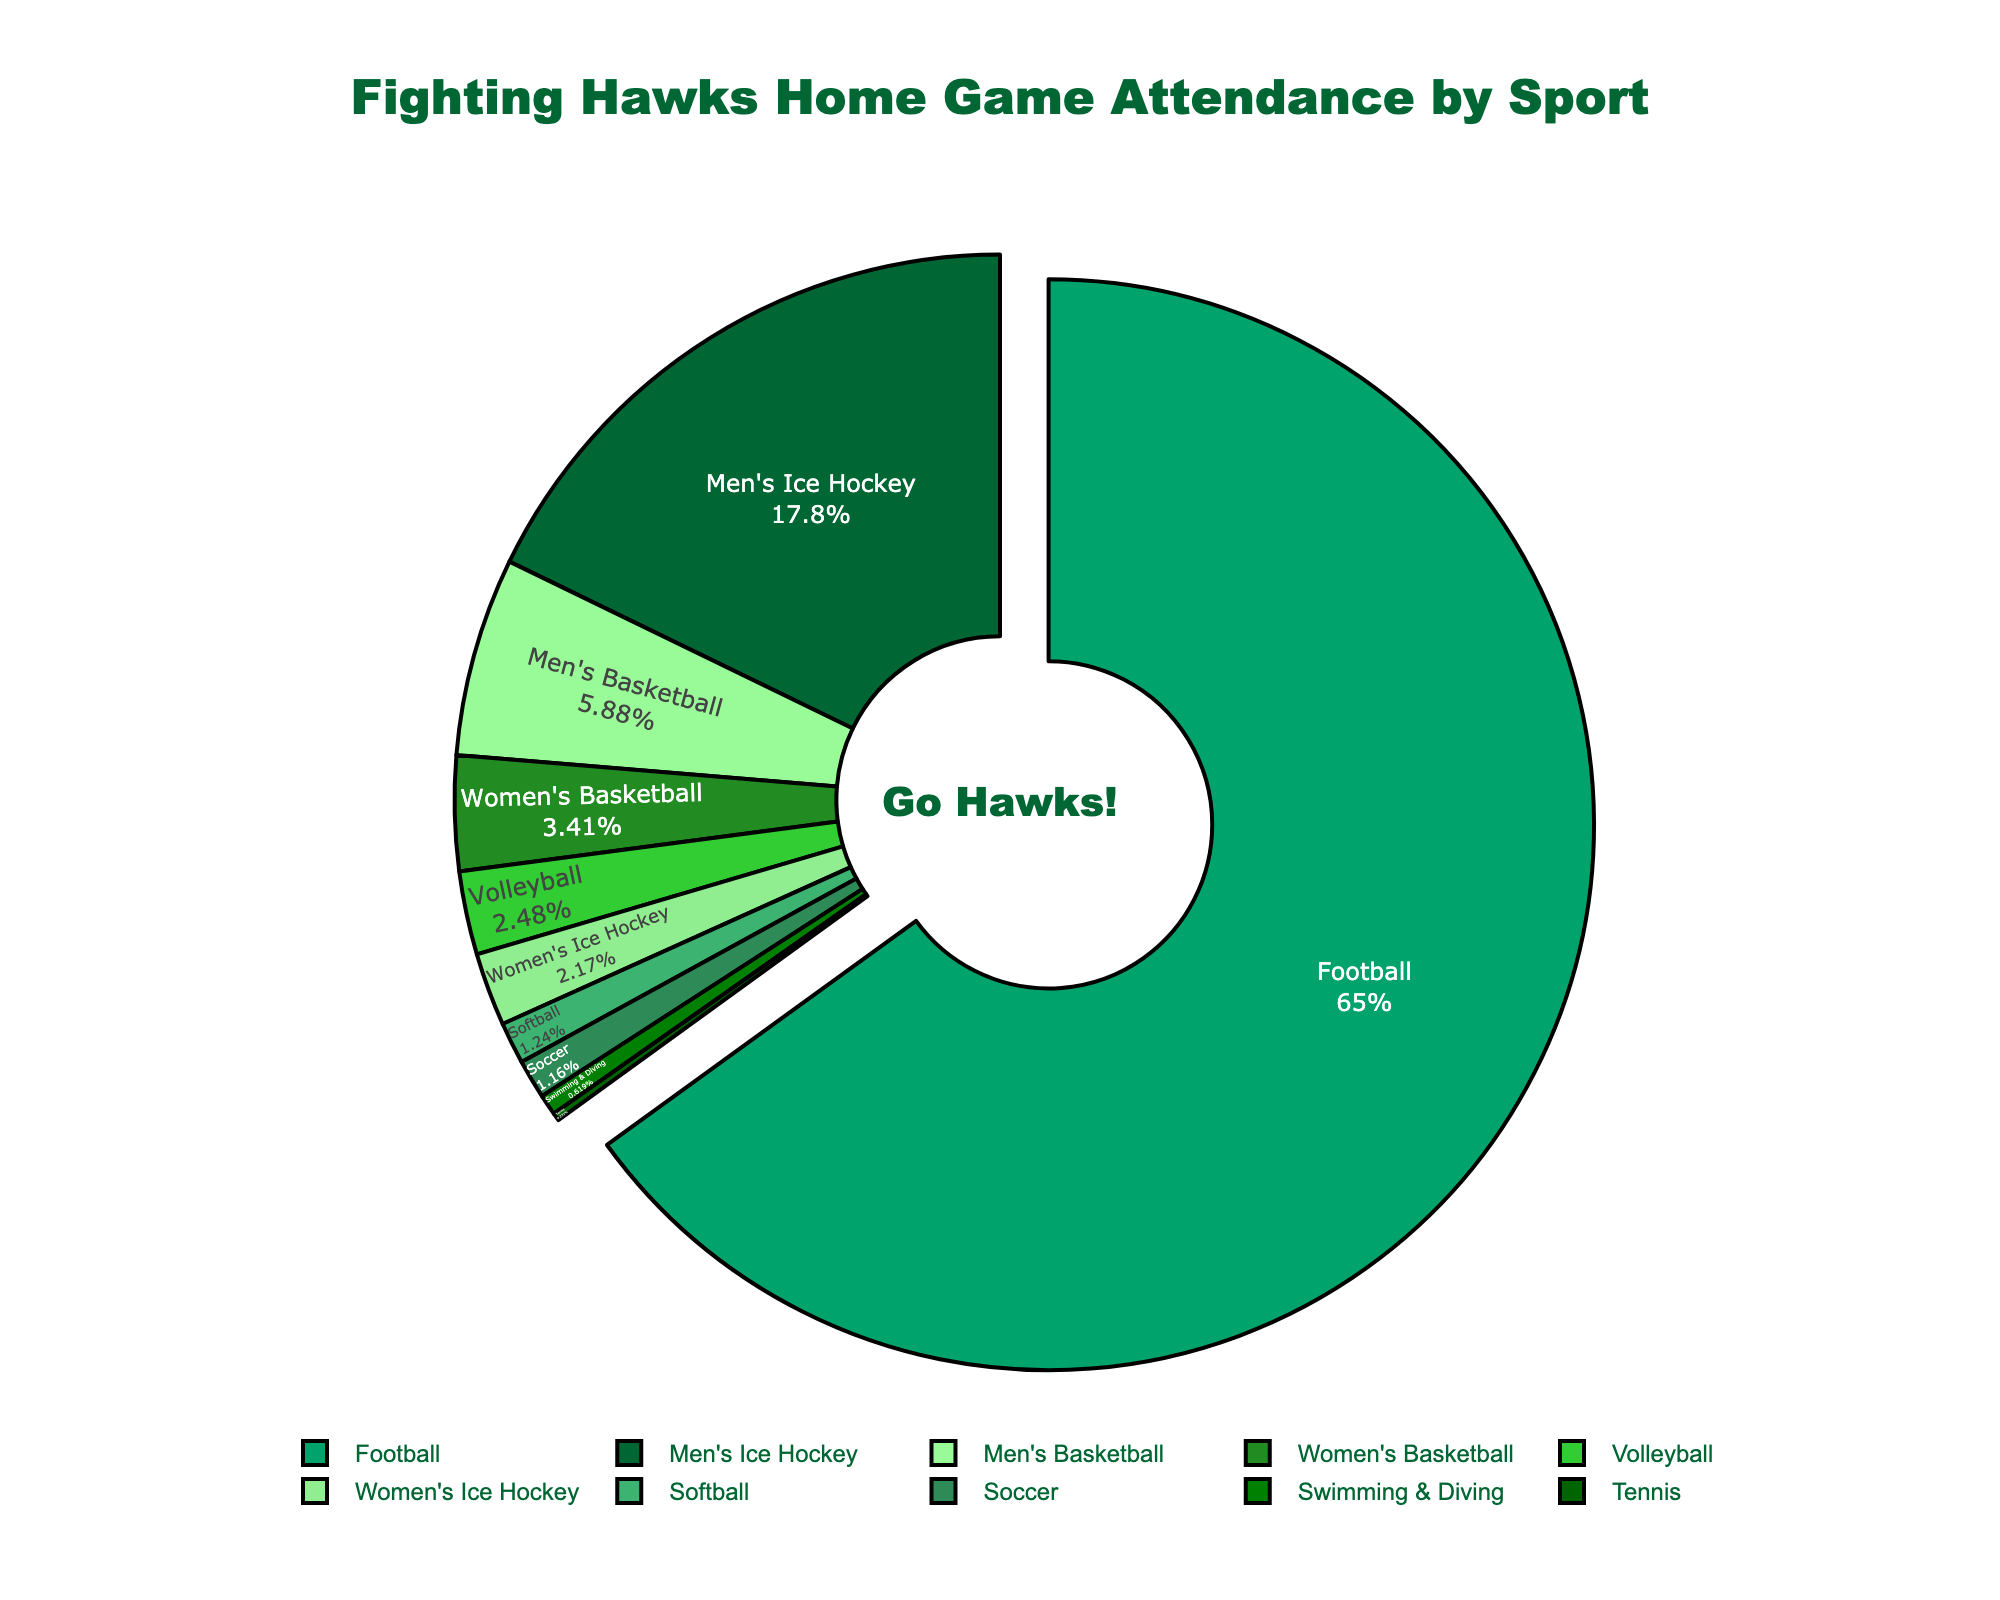Which sport has the highest attendance? By glancing at the pie chart, the segment for Football is the largest, indicating it has the highest attendance.
Answer: Football Which sport has the lowest attendance? The smallest segment in the pie chart represents Tennis, implying it has the lowest attendance.
Answer: Tennis How much more attendance does Men's Ice Hockey have compared to Women's Ice Hockey? From the pie chart, the attendance for Men's Ice Hockey is 11,500 and for Women's Ice Hockey is 1,400. The difference is 11,500 - 1,400 = 10,100.
Answer: 10,100 What percentage of total attendance is for Football? The pie chart shows labels with percentages; the segment for Football highlights its percentage.
Answer: 65.6% What is the combined attendance for both Basketball sports (Men's and Women's)? The attendance for Men's Basketball is 3,800 and for Women's Basketball is 2,200. The combined attendance is 3,800 + 2,200 = 6,000.
Answer: 6,000 Which sport has a higher attendance: Volleyball or Soccer? In the pie chart, the segment for Volleyball is slightly larger than that for Soccer, indicating higher attendance.
Answer: Volleyball What is the difference in attendance between Softball and Swimming & Diving? The attendance for Softball is 800 and for Swimming & Diving is 400. The difference is 800 - 400 = 400.
Answer: 400 What portion of total attendance do sports other than Football and Men's Ice Hockey make up? First, sum the total attendance for all sports (63,600). Then, add the attendance for Football (42,000) and Men's Ice Hockey (11,500). Subtracting these from the total: 63,600 - (42,000 + 11,500) = 10,100. The portion is 10,100 out of 63,600.
Answer: 15.9% Which sport falls in the middle when sorted by attendance from highest to lowest? Sorting the attendance values, the middle value is for Women's Basketball which is the 5th sport in a list of 10.
Answer: Women's Basketball Which sports have an attendance greater than 2,000 but less than 5,000? By reviewing the segments in the pie chart and their hover labels, we identify Men's Basketball (3,800) and Women's Basketball (2,200) fit this range.
Answer: Men's Basketball, Women's Basketball 